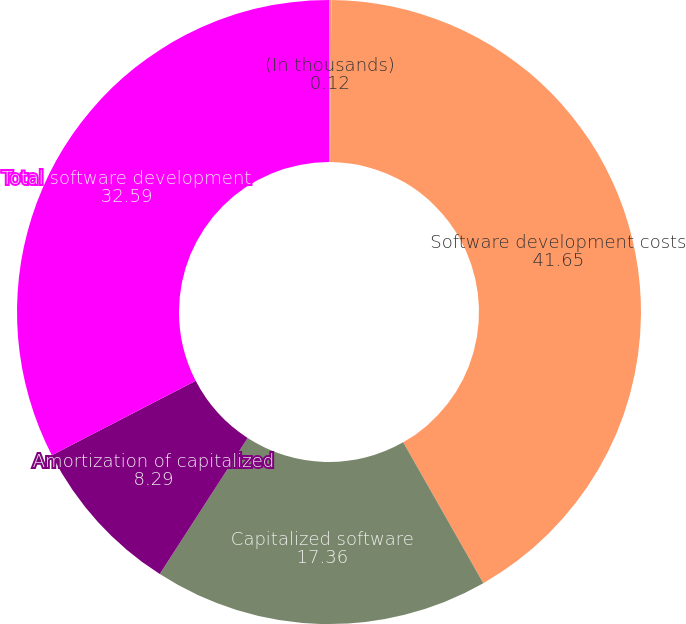Convert chart. <chart><loc_0><loc_0><loc_500><loc_500><pie_chart><fcel>(In thousands)<fcel>Software development costs<fcel>Capitalized software<fcel>Amortization of capitalized<fcel>Total software development<nl><fcel>0.12%<fcel>41.65%<fcel>17.36%<fcel>8.29%<fcel>32.59%<nl></chart> 